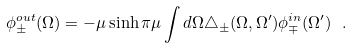<formula> <loc_0><loc_0><loc_500><loc_500>\phi ^ { o u t } _ { \pm } ( \Omega ) = - \mu \sinh \pi \mu \int d \Omega \triangle _ { \pm } ( \Omega , \Omega ^ { \prime } ) \phi ^ { i n } _ { \mp } ( \Omega ^ { \prime } ) \ .</formula> 